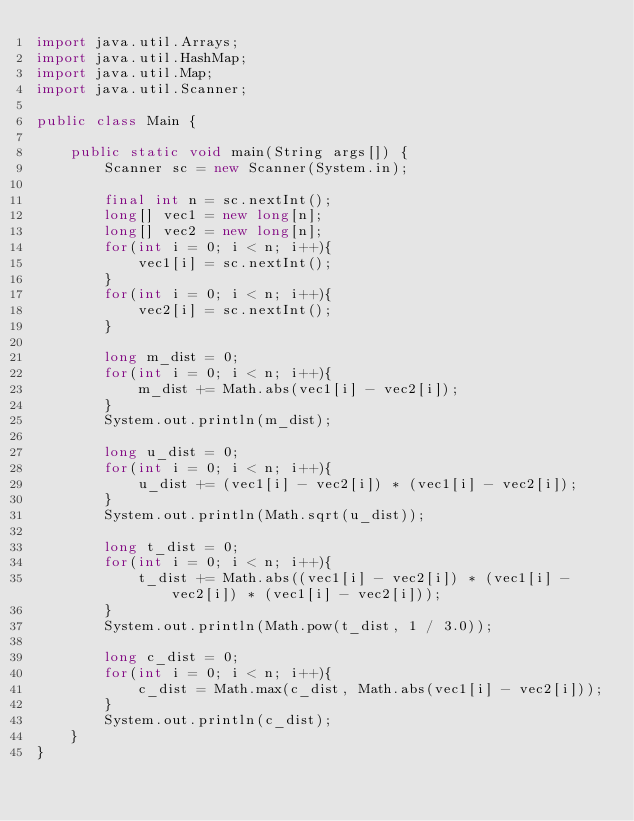Convert code to text. <code><loc_0><loc_0><loc_500><loc_500><_Java_>import java.util.Arrays;
import java.util.HashMap;
import java.util.Map;
import java.util.Scanner;
 
public class Main {
 
    public static void main(String args[]) {
        Scanner sc = new Scanner(System.in);
 
        final int n = sc.nextInt();
        long[] vec1 = new long[n];
        long[] vec2 = new long[n];
        for(int i = 0; i < n; i++){
            vec1[i] = sc.nextInt();
        }
        for(int i = 0; i < n; i++){
            vec2[i] = sc.nextInt();
        }
         
        long m_dist = 0;
        for(int i = 0; i < n; i++){
            m_dist += Math.abs(vec1[i] - vec2[i]);
        }
        System.out.println(m_dist);
         
        long u_dist = 0;
        for(int i = 0; i < n; i++){
            u_dist += (vec1[i] - vec2[i]) * (vec1[i] - vec2[i]);
        }
        System.out.println(Math.sqrt(u_dist));
         
        long t_dist = 0;
        for(int i = 0; i < n; i++){
            t_dist += Math.abs((vec1[i] - vec2[i]) * (vec1[i] - vec2[i]) * (vec1[i] - vec2[i]));
        }
        System.out.println(Math.pow(t_dist, 1 / 3.0));
         
        long c_dist = 0;
        for(int i = 0; i < n; i++){
            c_dist = Math.max(c_dist, Math.abs(vec1[i] - vec2[i]));
        }
        System.out.println(c_dist);
    }
}
</code> 